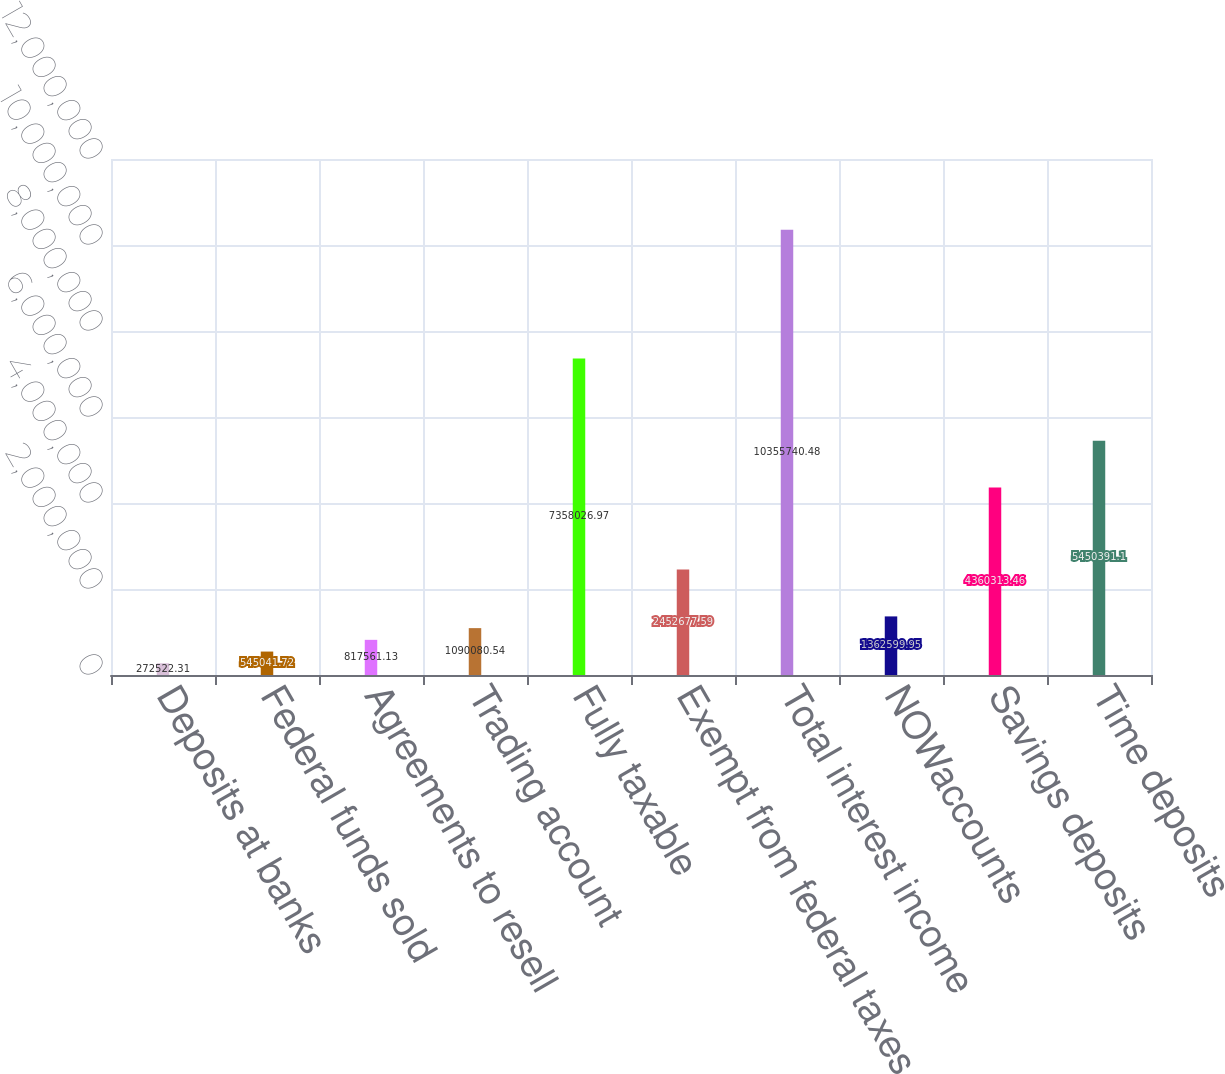Convert chart. <chart><loc_0><loc_0><loc_500><loc_500><bar_chart><fcel>Deposits at banks<fcel>Federal funds sold<fcel>Agreements to resell<fcel>Trading account<fcel>Fully taxable<fcel>Exempt from federal taxes<fcel>Total interest income<fcel>NOWaccounts<fcel>Savings deposits<fcel>Time deposits<nl><fcel>272522<fcel>545042<fcel>817561<fcel>1.09008e+06<fcel>7.35803e+06<fcel>2.45268e+06<fcel>1.03557e+07<fcel>1.3626e+06<fcel>4.36031e+06<fcel>5.45039e+06<nl></chart> 